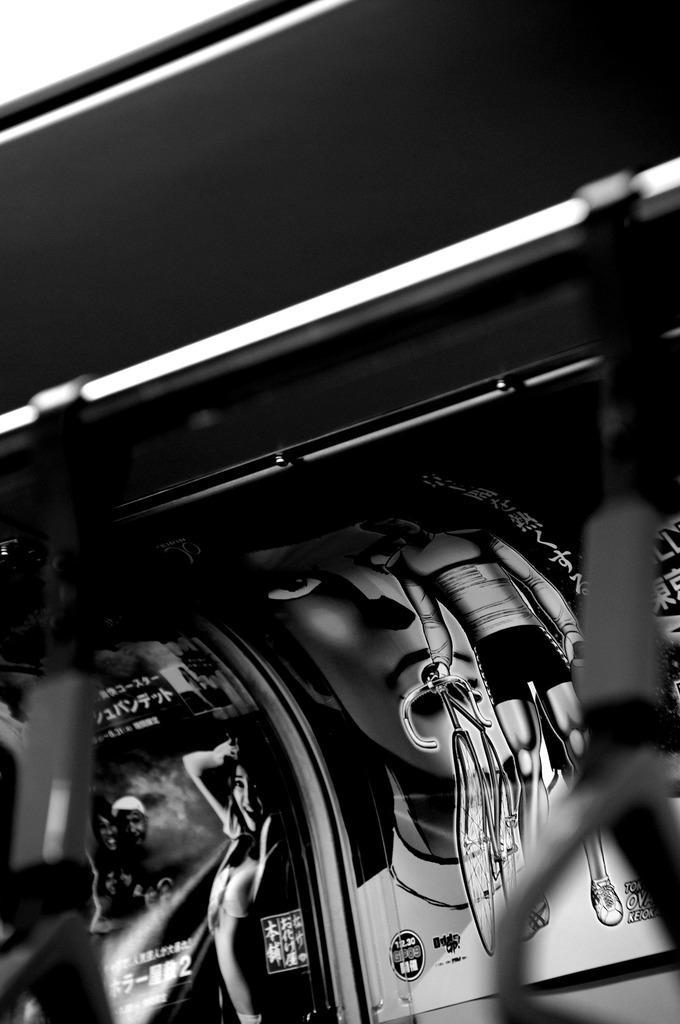Please provide a concise description of this image. In this image I can see the rod. In the background I can see few posts. 